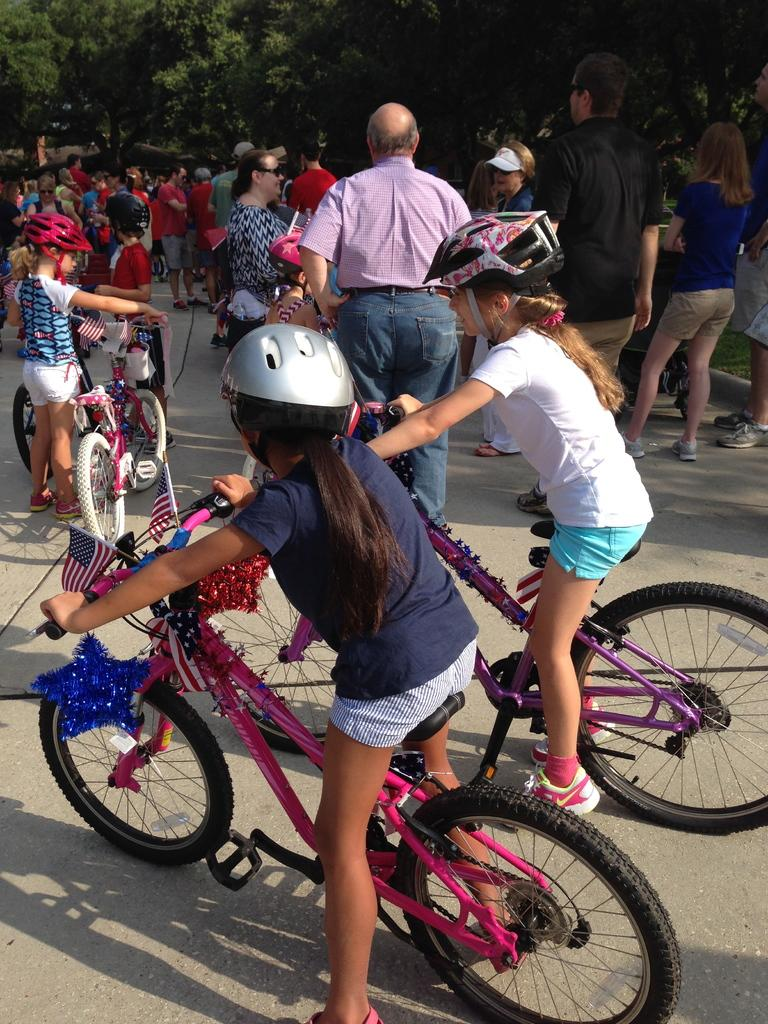What is happening in the image? There are children in the image, and they are riding bicycles. Are there any other people present in the image? Yes, there are people gathered around the children. What type of trucks can be seen in the image? There are no trucks present in the image. Who is serving juice to the children in the image? There is no mention of juice or a server in the image. 